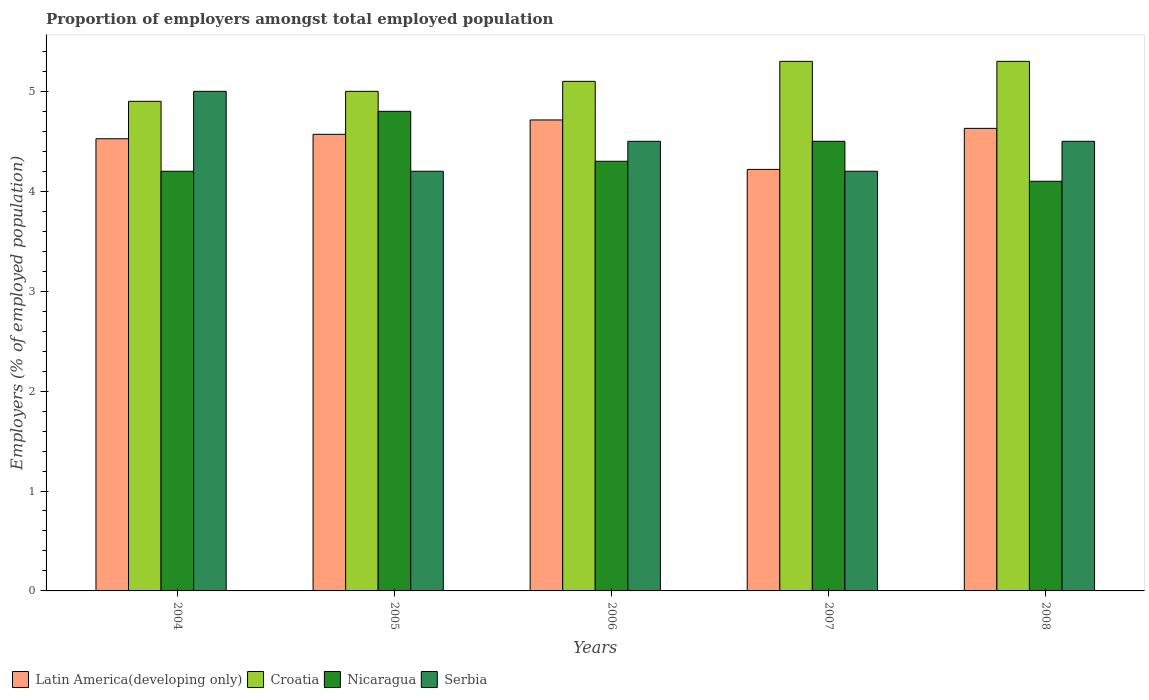How many bars are there on the 5th tick from the left?
Provide a succinct answer. 4. How many bars are there on the 5th tick from the right?
Make the answer very short. 4. What is the label of the 4th group of bars from the left?
Make the answer very short. 2007. In how many cases, is the number of bars for a given year not equal to the number of legend labels?
Ensure brevity in your answer.  0. What is the proportion of employers in Croatia in 2004?
Provide a short and direct response. 4.9. Across all years, what is the maximum proportion of employers in Croatia?
Offer a very short reply. 5.3. Across all years, what is the minimum proportion of employers in Serbia?
Your answer should be compact. 4.2. In which year was the proportion of employers in Nicaragua maximum?
Offer a very short reply. 2005. What is the total proportion of employers in Croatia in the graph?
Offer a very short reply. 25.6. What is the difference between the proportion of employers in Latin America(developing only) in 2004 and that in 2006?
Provide a short and direct response. -0.19. What is the difference between the proportion of employers in Croatia in 2008 and the proportion of employers in Nicaragua in 2004?
Provide a succinct answer. 1.1. What is the average proportion of employers in Latin America(developing only) per year?
Offer a terse response. 4.53. In the year 2007, what is the difference between the proportion of employers in Croatia and proportion of employers in Serbia?
Offer a very short reply. 1.1. What is the ratio of the proportion of employers in Nicaragua in 2005 to that in 2007?
Keep it short and to the point. 1.07. Is the proportion of employers in Nicaragua in 2004 less than that in 2006?
Offer a terse response. Yes. What is the difference between the highest and the lowest proportion of employers in Serbia?
Keep it short and to the point. 0.8. In how many years, is the proportion of employers in Croatia greater than the average proportion of employers in Croatia taken over all years?
Ensure brevity in your answer.  2. What does the 3rd bar from the left in 2004 represents?
Provide a succinct answer. Nicaragua. What does the 3rd bar from the right in 2006 represents?
Your response must be concise. Croatia. Is it the case that in every year, the sum of the proportion of employers in Serbia and proportion of employers in Nicaragua is greater than the proportion of employers in Latin America(developing only)?
Provide a short and direct response. Yes. Are all the bars in the graph horizontal?
Provide a succinct answer. No. How many years are there in the graph?
Give a very brief answer. 5. Does the graph contain any zero values?
Your answer should be very brief. No. Where does the legend appear in the graph?
Ensure brevity in your answer.  Bottom left. What is the title of the graph?
Provide a succinct answer. Proportion of employers amongst total employed population. Does "Uganda" appear as one of the legend labels in the graph?
Provide a succinct answer. No. What is the label or title of the Y-axis?
Make the answer very short. Employers (% of employed population). What is the Employers (% of employed population) of Latin America(developing only) in 2004?
Make the answer very short. 4.53. What is the Employers (% of employed population) of Croatia in 2004?
Give a very brief answer. 4.9. What is the Employers (% of employed population) of Nicaragua in 2004?
Provide a short and direct response. 4.2. What is the Employers (% of employed population) of Latin America(developing only) in 2005?
Ensure brevity in your answer.  4.57. What is the Employers (% of employed population) of Nicaragua in 2005?
Your response must be concise. 4.8. What is the Employers (% of employed population) in Serbia in 2005?
Offer a very short reply. 4.2. What is the Employers (% of employed population) of Latin America(developing only) in 2006?
Keep it short and to the point. 4.71. What is the Employers (% of employed population) in Croatia in 2006?
Provide a short and direct response. 5.1. What is the Employers (% of employed population) of Nicaragua in 2006?
Make the answer very short. 4.3. What is the Employers (% of employed population) in Latin America(developing only) in 2007?
Provide a short and direct response. 4.22. What is the Employers (% of employed population) of Croatia in 2007?
Offer a terse response. 5.3. What is the Employers (% of employed population) in Serbia in 2007?
Your answer should be compact. 4.2. What is the Employers (% of employed population) of Latin America(developing only) in 2008?
Give a very brief answer. 4.63. What is the Employers (% of employed population) in Croatia in 2008?
Make the answer very short. 5.3. What is the Employers (% of employed population) of Nicaragua in 2008?
Your answer should be very brief. 4.1. Across all years, what is the maximum Employers (% of employed population) in Latin America(developing only)?
Your answer should be very brief. 4.71. Across all years, what is the maximum Employers (% of employed population) in Croatia?
Make the answer very short. 5.3. Across all years, what is the maximum Employers (% of employed population) in Nicaragua?
Give a very brief answer. 4.8. Across all years, what is the maximum Employers (% of employed population) of Serbia?
Make the answer very short. 5. Across all years, what is the minimum Employers (% of employed population) of Latin America(developing only)?
Offer a very short reply. 4.22. Across all years, what is the minimum Employers (% of employed population) in Croatia?
Your answer should be compact. 4.9. Across all years, what is the minimum Employers (% of employed population) in Nicaragua?
Provide a succinct answer. 4.1. Across all years, what is the minimum Employers (% of employed population) in Serbia?
Your answer should be very brief. 4.2. What is the total Employers (% of employed population) in Latin America(developing only) in the graph?
Your answer should be compact. 22.66. What is the total Employers (% of employed population) of Croatia in the graph?
Provide a succinct answer. 25.6. What is the total Employers (% of employed population) of Nicaragua in the graph?
Give a very brief answer. 21.9. What is the total Employers (% of employed population) of Serbia in the graph?
Provide a succinct answer. 22.4. What is the difference between the Employers (% of employed population) in Latin America(developing only) in 2004 and that in 2005?
Provide a short and direct response. -0.04. What is the difference between the Employers (% of employed population) of Croatia in 2004 and that in 2005?
Your answer should be very brief. -0.1. What is the difference between the Employers (% of employed population) of Nicaragua in 2004 and that in 2005?
Give a very brief answer. -0.6. What is the difference between the Employers (% of employed population) in Latin America(developing only) in 2004 and that in 2006?
Your answer should be very brief. -0.19. What is the difference between the Employers (% of employed population) in Croatia in 2004 and that in 2006?
Your answer should be compact. -0.2. What is the difference between the Employers (% of employed population) in Serbia in 2004 and that in 2006?
Your answer should be very brief. 0.5. What is the difference between the Employers (% of employed population) in Latin America(developing only) in 2004 and that in 2007?
Offer a very short reply. 0.31. What is the difference between the Employers (% of employed population) of Croatia in 2004 and that in 2007?
Provide a short and direct response. -0.4. What is the difference between the Employers (% of employed population) in Nicaragua in 2004 and that in 2007?
Offer a very short reply. -0.3. What is the difference between the Employers (% of employed population) in Latin America(developing only) in 2004 and that in 2008?
Your answer should be compact. -0.1. What is the difference between the Employers (% of employed population) of Croatia in 2004 and that in 2008?
Offer a terse response. -0.4. What is the difference between the Employers (% of employed population) in Nicaragua in 2004 and that in 2008?
Your answer should be very brief. 0.1. What is the difference between the Employers (% of employed population) in Serbia in 2004 and that in 2008?
Make the answer very short. 0.5. What is the difference between the Employers (% of employed population) in Latin America(developing only) in 2005 and that in 2006?
Your response must be concise. -0.14. What is the difference between the Employers (% of employed population) of Croatia in 2005 and that in 2006?
Give a very brief answer. -0.1. What is the difference between the Employers (% of employed population) in Nicaragua in 2005 and that in 2006?
Your answer should be compact. 0.5. What is the difference between the Employers (% of employed population) in Latin America(developing only) in 2005 and that in 2007?
Offer a terse response. 0.35. What is the difference between the Employers (% of employed population) of Croatia in 2005 and that in 2007?
Your answer should be compact. -0.3. What is the difference between the Employers (% of employed population) of Nicaragua in 2005 and that in 2007?
Keep it short and to the point. 0.3. What is the difference between the Employers (% of employed population) in Serbia in 2005 and that in 2007?
Provide a succinct answer. 0. What is the difference between the Employers (% of employed population) of Latin America(developing only) in 2005 and that in 2008?
Give a very brief answer. -0.06. What is the difference between the Employers (% of employed population) in Nicaragua in 2005 and that in 2008?
Ensure brevity in your answer.  0.7. What is the difference between the Employers (% of employed population) in Latin America(developing only) in 2006 and that in 2007?
Offer a terse response. 0.49. What is the difference between the Employers (% of employed population) in Nicaragua in 2006 and that in 2007?
Your answer should be compact. -0.2. What is the difference between the Employers (% of employed population) in Serbia in 2006 and that in 2007?
Your response must be concise. 0.3. What is the difference between the Employers (% of employed population) of Latin America(developing only) in 2006 and that in 2008?
Your answer should be compact. 0.08. What is the difference between the Employers (% of employed population) in Serbia in 2006 and that in 2008?
Your response must be concise. 0. What is the difference between the Employers (% of employed population) in Latin America(developing only) in 2007 and that in 2008?
Your answer should be very brief. -0.41. What is the difference between the Employers (% of employed population) in Croatia in 2007 and that in 2008?
Make the answer very short. 0. What is the difference between the Employers (% of employed population) of Nicaragua in 2007 and that in 2008?
Provide a short and direct response. 0.4. What is the difference between the Employers (% of employed population) of Latin America(developing only) in 2004 and the Employers (% of employed population) of Croatia in 2005?
Your response must be concise. -0.47. What is the difference between the Employers (% of employed population) of Latin America(developing only) in 2004 and the Employers (% of employed population) of Nicaragua in 2005?
Ensure brevity in your answer.  -0.27. What is the difference between the Employers (% of employed population) in Latin America(developing only) in 2004 and the Employers (% of employed population) in Serbia in 2005?
Your answer should be very brief. 0.33. What is the difference between the Employers (% of employed population) of Latin America(developing only) in 2004 and the Employers (% of employed population) of Croatia in 2006?
Provide a short and direct response. -0.57. What is the difference between the Employers (% of employed population) of Latin America(developing only) in 2004 and the Employers (% of employed population) of Nicaragua in 2006?
Offer a terse response. 0.23. What is the difference between the Employers (% of employed population) of Latin America(developing only) in 2004 and the Employers (% of employed population) of Serbia in 2006?
Offer a very short reply. 0.03. What is the difference between the Employers (% of employed population) of Croatia in 2004 and the Employers (% of employed population) of Nicaragua in 2006?
Keep it short and to the point. 0.6. What is the difference between the Employers (% of employed population) of Croatia in 2004 and the Employers (% of employed population) of Serbia in 2006?
Ensure brevity in your answer.  0.4. What is the difference between the Employers (% of employed population) in Nicaragua in 2004 and the Employers (% of employed population) in Serbia in 2006?
Offer a very short reply. -0.3. What is the difference between the Employers (% of employed population) in Latin America(developing only) in 2004 and the Employers (% of employed population) in Croatia in 2007?
Ensure brevity in your answer.  -0.77. What is the difference between the Employers (% of employed population) of Latin America(developing only) in 2004 and the Employers (% of employed population) of Nicaragua in 2007?
Offer a very short reply. 0.03. What is the difference between the Employers (% of employed population) in Latin America(developing only) in 2004 and the Employers (% of employed population) in Serbia in 2007?
Ensure brevity in your answer.  0.33. What is the difference between the Employers (% of employed population) in Latin America(developing only) in 2004 and the Employers (% of employed population) in Croatia in 2008?
Ensure brevity in your answer.  -0.77. What is the difference between the Employers (% of employed population) of Latin America(developing only) in 2004 and the Employers (% of employed population) of Nicaragua in 2008?
Keep it short and to the point. 0.43. What is the difference between the Employers (% of employed population) in Latin America(developing only) in 2004 and the Employers (% of employed population) in Serbia in 2008?
Ensure brevity in your answer.  0.03. What is the difference between the Employers (% of employed population) in Croatia in 2004 and the Employers (% of employed population) in Nicaragua in 2008?
Ensure brevity in your answer.  0.8. What is the difference between the Employers (% of employed population) in Latin America(developing only) in 2005 and the Employers (% of employed population) in Croatia in 2006?
Offer a very short reply. -0.53. What is the difference between the Employers (% of employed population) in Latin America(developing only) in 2005 and the Employers (% of employed population) in Nicaragua in 2006?
Provide a succinct answer. 0.27. What is the difference between the Employers (% of employed population) in Latin America(developing only) in 2005 and the Employers (% of employed population) in Serbia in 2006?
Your response must be concise. 0.07. What is the difference between the Employers (% of employed population) in Croatia in 2005 and the Employers (% of employed population) in Nicaragua in 2006?
Provide a succinct answer. 0.7. What is the difference between the Employers (% of employed population) of Croatia in 2005 and the Employers (% of employed population) of Serbia in 2006?
Offer a very short reply. 0.5. What is the difference between the Employers (% of employed population) in Latin America(developing only) in 2005 and the Employers (% of employed population) in Croatia in 2007?
Offer a very short reply. -0.73. What is the difference between the Employers (% of employed population) of Latin America(developing only) in 2005 and the Employers (% of employed population) of Nicaragua in 2007?
Ensure brevity in your answer.  0.07. What is the difference between the Employers (% of employed population) of Latin America(developing only) in 2005 and the Employers (% of employed population) of Serbia in 2007?
Your answer should be very brief. 0.37. What is the difference between the Employers (% of employed population) in Croatia in 2005 and the Employers (% of employed population) in Nicaragua in 2007?
Your answer should be compact. 0.5. What is the difference between the Employers (% of employed population) in Latin America(developing only) in 2005 and the Employers (% of employed population) in Croatia in 2008?
Offer a very short reply. -0.73. What is the difference between the Employers (% of employed population) in Latin America(developing only) in 2005 and the Employers (% of employed population) in Nicaragua in 2008?
Make the answer very short. 0.47. What is the difference between the Employers (% of employed population) in Latin America(developing only) in 2005 and the Employers (% of employed population) in Serbia in 2008?
Make the answer very short. 0.07. What is the difference between the Employers (% of employed population) in Croatia in 2005 and the Employers (% of employed population) in Nicaragua in 2008?
Your answer should be very brief. 0.9. What is the difference between the Employers (% of employed population) in Nicaragua in 2005 and the Employers (% of employed population) in Serbia in 2008?
Offer a terse response. 0.3. What is the difference between the Employers (% of employed population) in Latin America(developing only) in 2006 and the Employers (% of employed population) in Croatia in 2007?
Your response must be concise. -0.59. What is the difference between the Employers (% of employed population) in Latin America(developing only) in 2006 and the Employers (% of employed population) in Nicaragua in 2007?
Your response must be concise. 0.21. What is the difference between the Employers (% of employed population) of Latin America(developing only) in 2006 and the Employers (% of employed population) of Serbia in 2007?
Your response must be concise. 0.51. What is the difference between the Employers (% of employed population) in Croatia in 2006 and the Employers (% of employed population) in Nicaragua in 2007?
Offer a terse response. 0.6. What is the difference between the Employers (% of employed population) in Croatia in 2006 and the Employers (% of employed population) in Serbia in 2007?
Your response must be concise. 0.9. What is the difference between the Employers (% of employed population) in Nicaragua in 2006 and the Employers (% of employed population) in Serbia in 2007?
Provide a short and direct response. 0.1. What is the difference between the Employers (% of employed population) of Latin America(developing only) in 2006 and the Employers (% of employed population) of Croatia in 2008?
Offer a very short reply. -0.59. What is the difference between the Employers (% of employed population) in Latin America(developing only) in 2006 and the Employers (% of employed population) in Nicaragua in 2008?
Give a very brief answer. 0.61. What is the difference between the Employers (% of employed population) in Latin America(developing only) in 2006 and the Employers (% of employed population) in Serbia in 2008?
Your response must be concise. 0.21. What is the difference between the Employers (% of employed population) of Latin America(developing only) in 2007 and the Employers (% of employed population) of Croatia in 2008?
Provide a succinct answer. -1.08. What is the difference between the Employers (% of employed population) of Latin America(developing only) in 2007 and the Employers (% of employed population) of Nicaragua in 2008?
Offer a very short reply. 0.12. What is the difference between the Employers (% of employed population) in Latin America(developing only) in 2007 and the Employers (% of employed population) in Serbia in 2008?
Your response must be concise. -0.28. What is the difference between the Employers (% of employed population) of Croatia in 2007 and the Employers (% of employed population) of Nicaragua in 2008?
Offer a very short reply. 1.2. What is the average Employers (% of employed population) in Latin America(developing only) per year?
Your response must be concise. 4.53. What is the average Employers (% of employed population) in Croatia per year?
Give a very brief answer. 5.12. What is the average Employers (% of employed population) of Nicaragua per year?
Provide a short and direct response. 4.38. What is the average Employers (% of employed population) of Serbia per year?
Provide a short and direct response. 4.48. In the year 2004, what is the difference between the Employers (% of employed population) of Latin America(developing only) and Employers (% of employed population) of Croatia?
Keep it short and to the point. -0.37. In the year 2004, what is the difference between the Employers (% of employed population) in Latin America(developing only) and Employers (% of employed population) in Nicaragua?
Offer a very short reply. 0.33. In the year 2004, what is the difference between the Employers (% of employed population) of Latin America(developing only) and Employers (% of employed population) of Serbia?
Give a very brief answer. -0.47. In the year 2004, what is the difference between the Employers (% of employed population) of Croatia and Employers (% of employed population) of Nicaragua?
Your answer should be compact. 0.7. In the year 2005, what is the difference between the Employers (% of employed population) of Latin America(developing only) and Employers (% of employed population) of Croatia?
Your answer should be very brief. -0.43. In the year 2005, what is the difference between the Employers (% of employed population) in Latin America(developing only) and Employers (% of employed population) in Nicaragua?
Give a very brief answer. -0.23. In the year 2005, what is the difference between the Employers (% of employed population) in Latin America(developing only) and Employers (% of employed population) in Serbia?
Make the answer very short. 0.37. In the year 2005, what is the difference between the Employers (% of employed population) of Croatia and Employers (% of employed population) of Nicaragua?
Your answer should be compact. 0.2. In the year 2006, what is the difference between the Employers (% of employed population) of Latin America(developing only) and Employers (% of employed population) of Croatia?
Your answer should be compact. -0.39. In the year 2006, what is the difference between the Employers (% of employed population) in Latin America(developing only) and Employers (% of employed population) in Nicaragua?
Give a very brief answer. 0.41. In the year 2006, what is the difference between the Employers (% of employed population) in Latin America(developing only) and Employers (% of employed population) in Serbia?
Provide a short and direct response. 0.21. In the year 2006, what is the difference between the Employers (% of employed population) of Croatia and Employers (% of employed population) of Nicaragua?
Your answer should be compact. 0.8. In the year 2006, what is the difference between the Employers (% of employed population) in Nicaragua and Employers (% of employed population) in Serbia?
Keep it short and to the point. -0.2. In the year 2007, what is the difference between the Employers (% of employed population) of Latin America(developing only) and Employers (% of employed population) of Croatia?
Offer a very short reply. -1.08. In the year 2007, what is the difference between the Employers (% of employed population) in Latin America(developing only) and Employers (% of employed population) in Nicaragua?
Offer a terse response. -0.28. In the year 2007, what is the difference between the Employers (% of employed population) of Latin America(developing only) and Employers (% of employed population) of Serbia?
Keep it short and to the point. 0.02. In the year 2007, what is the difference between the Employers (% of employed population) of Croatia and Employers (% of employed population) of Nicaragua?
Ensure brevity in your answer.  0.8. In the year 2007, what is the difference between the Employers (% of employed population) of Croatia and Employers (% of employed population) of Serbia?
Ensure brevity in your answer.  1.1. In the year 2008, what is the difference between the Employers (% of employed population) in Latin America(developing only) and Employers (% of employed population) in Croatia?
Your answer should be compact. -0.67. In the year 2008, what is the difference between the Employers (% of employed population) in Latin America(developing only) and Employers (% of employed population) in Nicaragua?
Keep it short and to the point. 0.53. In the year 2008, what is the difference between the Employers (% of employed population) in Latin America(developing only) and Employers (% of employed population) in Serbia?
Make the answer very short. 0.13. In the year 2008, what is the difference between the Employers (% of employed population) of Croatia and Employers (% of employed population) of Nicaragua?
Offer a very short reply. 1.2. In the year 2008, what is the difference between the Employers (% of employed population) of Croatia and Employers (% of employed population) of Serbia?
Offer a terse response. 0.8. What is the ratio of the Employers (% of employed population) of Latin America(developing only) in 2004 to that in 2005?
Provide a short and direct response. 0.99. What is the ratio of the Employers (% of employed population) in Serbia in 2004 to that in 2005?
Make the answer very short. 1.19. What is the ratio of the Employers (% of employed population) in Latin America(developing only) in 2004 to that in 2006?
Your response must be concise. 0.96. What is the ratio of the Employers (% of employed population) of Croatia in 2004 to that in 2006?
Make the answer very short. 0.96. What is the ratio of the Employers (% of employed population) of Nicaragua in 2004 to that in 2006?
Your response must be concise. 0.98. What is the ratio of the Employers (% of employed population) in Latin America(developing only) in 2004 to that in 2007?
Your answer should be compact. 1.07. What is the ratio of the Employers (% of employed population) in Croatia in 2004 to that in 2007?
Provide a short and direct response. 0.92. What is the ratio of the Employers (% of employed population) of Nicaragua in 2004 to that in 2007?
Ensure brevity in your answer.  0.93. What is the ratio of the Employers (% of employed population) of Serbia in 2004 to that in 2007?
Your answer should be compact. 1.19. What is the ratio of the Employers (% of employed population) in Latin America(developing only) in 2004 to that in 2008?
Ensure brevity in your answer.  0.98. What is the ratio of the Employers (% of employed population) in Croatia in 2004 to that in 2008?
Give a very brief answer. 0.92. What is the ratio of the Employers (% of employed population) of Nicaragua in 2004 to that in 2008?
Make the answer very short. 1.02. What is the ratio of the Employers (% of employed population) in Serbia in 2004 to that in 2008?
Offer a terse response. 1.11. What is the ratio of the Employers (% of employed population) of Latin America(developing only) in 2005 to that in 2006?
Provide a short and direct response. 0.97. What is the ratio of the Employers (% of employed population) in Croatia in 2005 to that in 2006?
Offer a very short reply. 0.98. What is the ratio of the Employers (% of employed population) of Nicaragua in 2005 to that in 2006?
Offer a very short reply. 1.12. What is the ratio of the Employers (% of employed population) in Serbia in 2005 to that in 2006?
Offer a terse response. 0.93. What is the ratio of the Employers (% of employed population) of Latin America(developing only) in 2005 to that in 2007?
Your response must be concise. 1.08. What is the ratio of the Employers (% of employed population) in Croatia in 2005 to that in 2007?
Provide a short and direct response. 0.94. What is the ratio of the Employers (% of employed population) of Nicaragua in 2005 to that in 2007?
Make the answer very short. 1.07. What is the ratio of the Employers (% of employed population) of Serbia in 2005 to that in 2007?
Your response must be concise. 1. What is the ratio of the Employers (% of employed population) in Latin America(developing only) in 2005 to that in 2008?
Ensure brevity in your answer.  0.99. What is the ratio of the Employers (% of employed population) in Croatia in 2005 to that in 2008?
Your response must be concise. 0.94. What is the ratio of the Employers (% of employed population) in Nicaragua in 2005 to that in 2008?
Ensure brevity in your answer.  1.17. What is the ratio of the Employers (% of employed population) of Serbia in 2005 to that in 2008?
Make the answer very short. 0.93. What is the ratio of the Employers (% of employed population) in Latin America(developing only) in 2006 to that in 2007?
Your response must be concise. 1.12. What is the ratio of the Employers (% of employed population) of Croatia in 2006 to that in 2007?
Keep it short and to the point. 0.96. What is the ratio of the Employers (% of employed population) of Nicaragua in 2006 to that in 2007?
Give a very brief answer. 0.96. What is the ratio of the Employers (% of employed population) of Serbia in 2006 to that in 2007?
Offer a terse response. 1.07. What is the ratio of the Employers (% of employed population) in Latin America(developing only) in 2006 to that in 2008?
Your response must be concise. 1.02. What is the ratio of the Employers (% of employed population) of Croatia in 2006 to that in 2008?
Offer a terse response. 0.96. What is the ratio of the Employers (% of employed population) of Nicaragua in 2006 to that in 2008?
Make the answer very short. 1.05. What is the ratio of the Employers (% of employed population) in Latin America(developing only) in 2007 to that in 2008?
Give a very brief answer. 0.91. What is the ratio of the Employers (% of employed population) in Nicaragua in 2007 to that in 2008?
Provide a short and direct response. 1.1. What is the difference between the highest and the second highest Employers (% of employed population) in Latin America(developing only)?
Ensure brevity in your answer.  0.08. What is the difference between the highest and the second highest Employers (% of employed population) in Nicaragua?
Your answer should be very brief. 0.3. What is the difference between the highest and the lowest Employers (% of employed population) of Latin America(developing only)?
Your response must be concise. 0.49. What is the difference between the highest and the lowest Employers (% of employed population) of Croatia?
Make the answer very short. 0.4. 